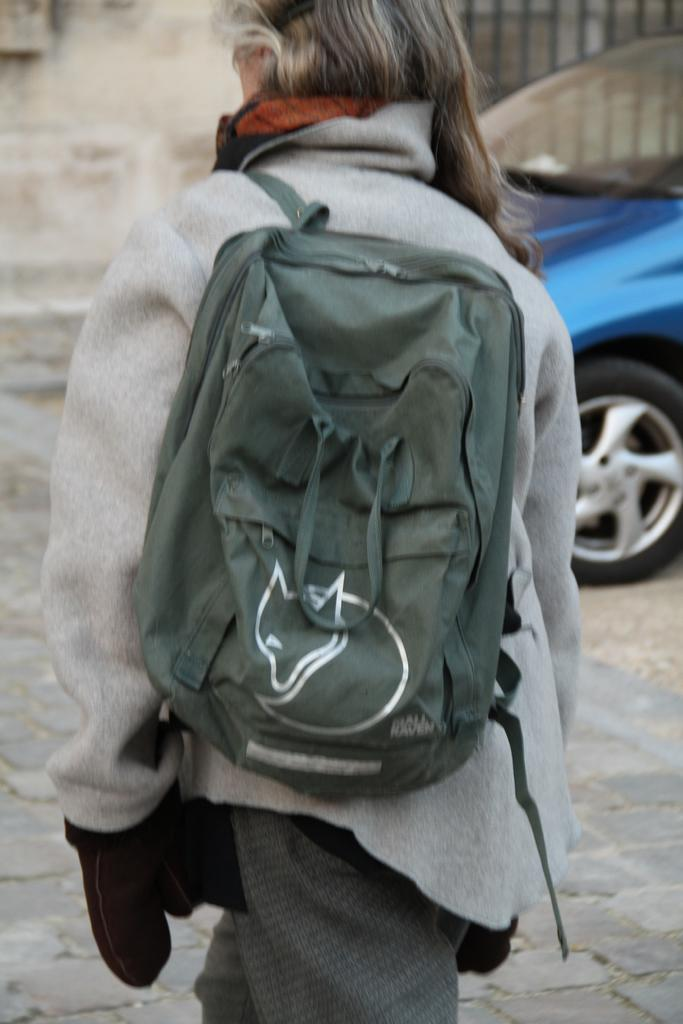Who is present in the image? There is a woman in the image. What is the woman wearing? The woman is wearing a bag. What can be seen on the road in the image? There is a car on the road in the image. How does the sheet of paper interact with the cable in the image? There is no sheet of paper or cable present in the image. 